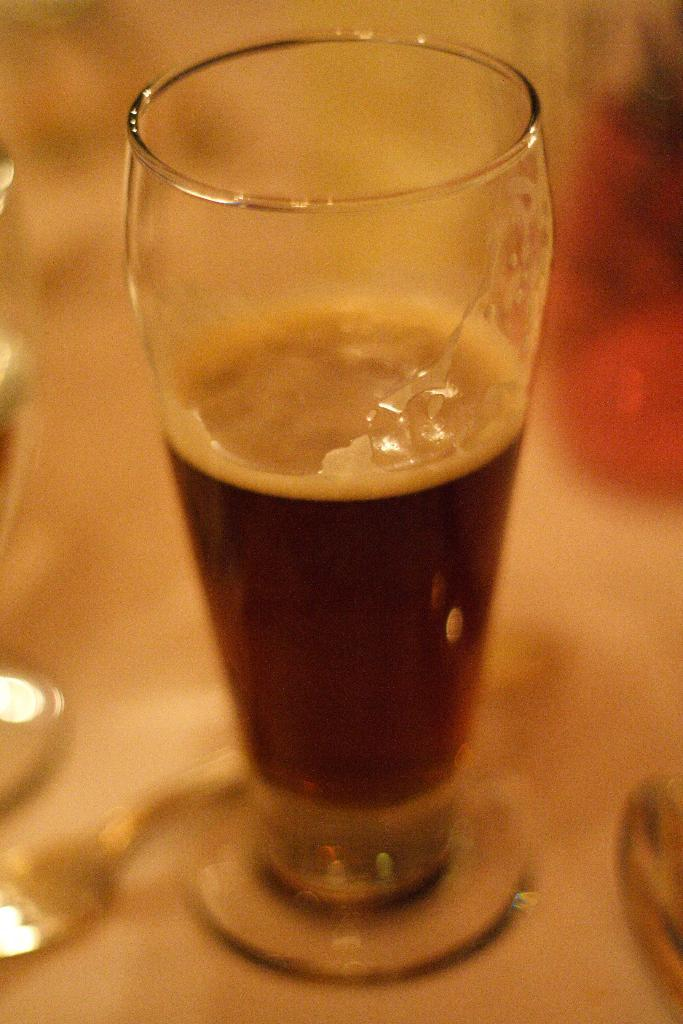What is in the glass that is visible in the image? There is a drink in the glass in the image. What can be seen on the platform in the image? There are objects on the platform in the image. How would you describe the background of the image? The background of the image is blurry. Is there a farmer tending to the objects on the platform in the image? There is no farmer present in the image, and the objects on the platform are not being tended to. What type of books can be seen on the platform in the image? There are no books visible on the platform in the image. 